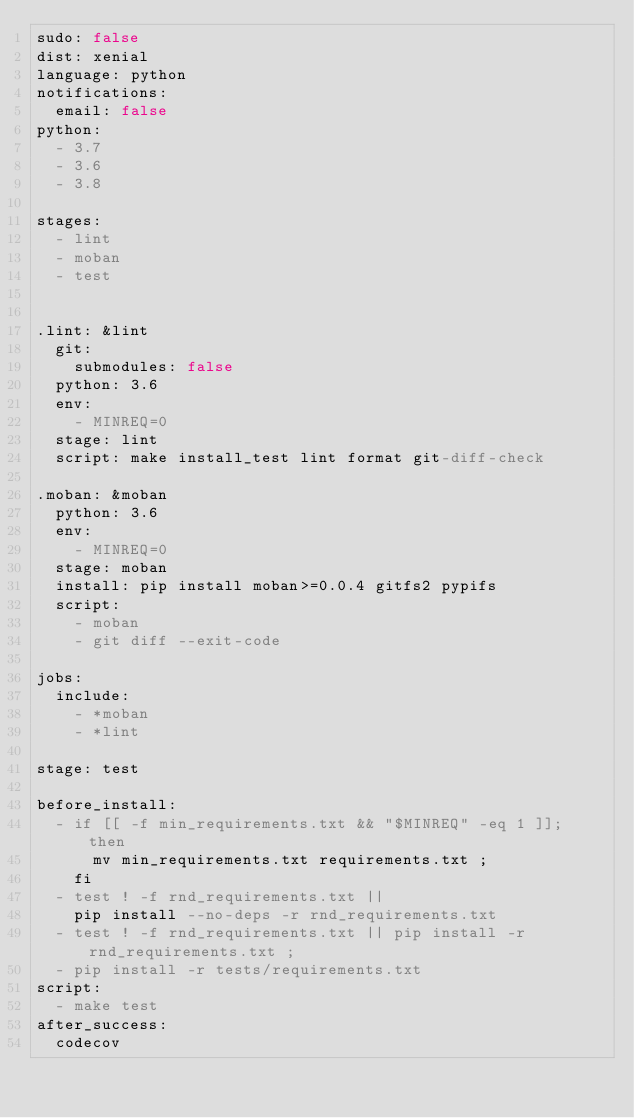<code> <loc_0><loc_0><loc_500><loc_500><_YAML_>sudo: false
dist: xenial
language: python
notifications:
  email: false
python:
  - 3.7
  - 3.6
  - 3.8

stages:
  - lint
  - moban
  - test


.lint: &lint
  git:
    submodules: false
  python: 3.6
  env:
    - MINREQ=0
  stage: lint
  script: make install_test lint format git-diff-check

.moban: &moban
  python: 3.6
  env:
    - MINREQ=0
  stage: moban
  install: pip install moban>=0.0.4 gitfs2 pypifs
  script:
    - moban
    - git diff --exit-code

jobs:
  include:
    - *moban
    - *lint

stage: test

before_install:
  - if [[ -f min_requirements.txt && "$MINREQ" -eq 1 ]]; then
      mv min_requirements.txt requirements.txt ;
    fi
  - test ! -f rnd_requirements.txt ||
    pip install --no-deps -r rnd_requirements.txt
  - test ! -f rnd_requirements.txt || pip install -r rnd_requirements.txt ;
  - pip install -r tests/requirements.txt
script:
  - make test
after_success:
  codecov
</code> 